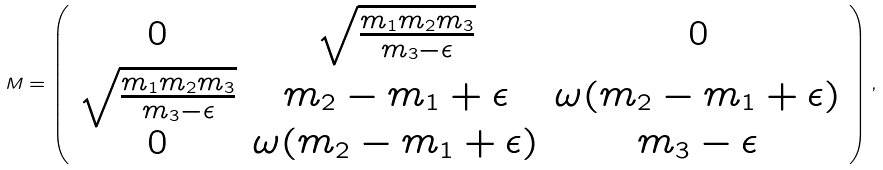Convert formula to latex. <formula><loc_0><loc_0><loc_500><loc_500>M = \left ( \begin{array} { c c c } 0 & \sqrt { \frac { m _ { 1 } m _ { 2 } m _ { 3 } } { m _ { 3 } - \epsilon } } & 0 \\ \sqrt { \frac { m _ { 1 } m _ { 2 } m _ { 3 } } { m _ { 3 } - \epsilon } } & m _ { 2 } - m _ { 1 } + \epsilon & \omega ( m _ { 2 } - m _ { 1 } + \epsilon ) \\ 0 & \omega ( m _ { 2 } - m _ { 1 } + \epsilon ) & m _ { 3 } - \epsilon \end{array} \right ) ,</formula> 